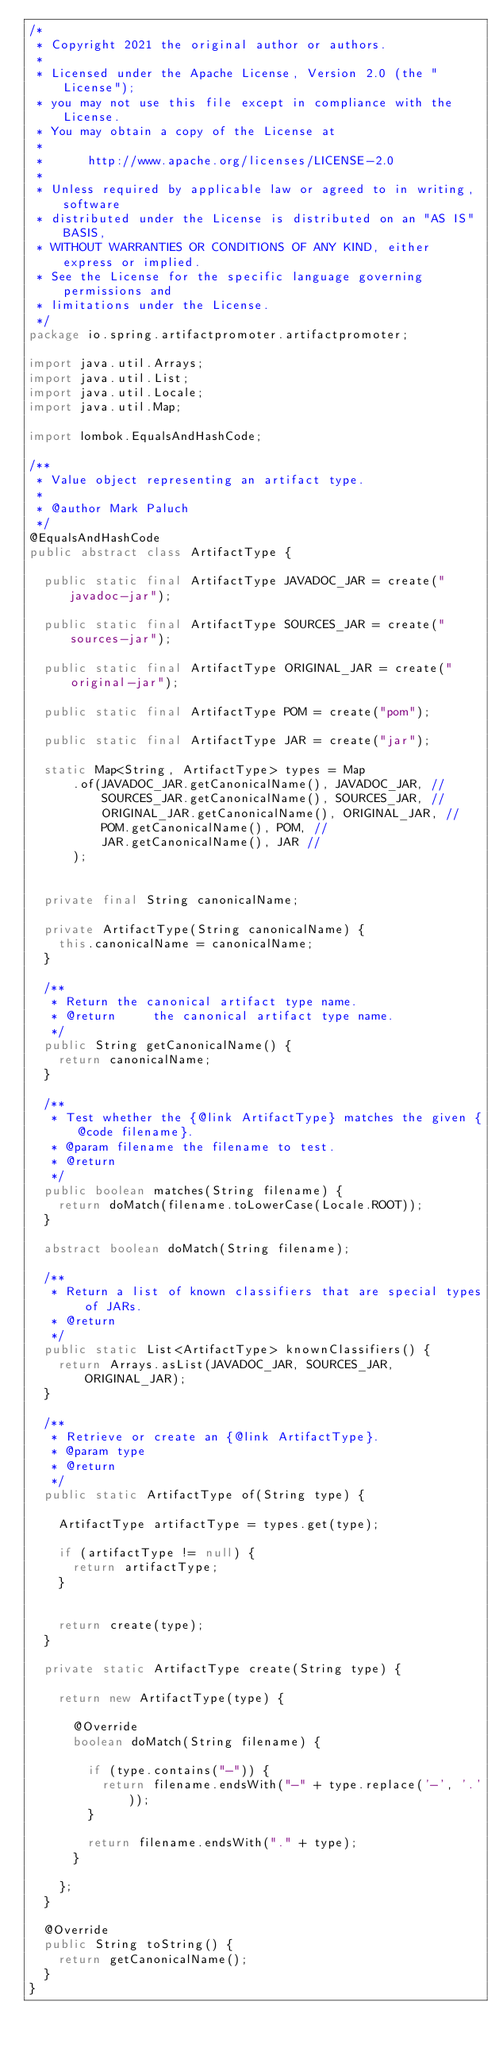Convert code to text. <code><loc_0><loc_0><loc_500><loc_500><_Java_>/*
 * Copyright 2021 the original author or authors.
 *
 * Licensed under the Apache License, Version 2.0 (the "License");
 * you may not use this file except in compliance with the License.
 * You may obtain a copy of the License at
 *
 *      http://www.apache.org/licenses/LICENSE-2.0
 *
 * Unless required by applicable law or agreed to in writing, software
 * distributed under the License is distributed on an "AS IS" BASIS,
 * WITHOUT WARRANTIES OR CONDITIONS OF ANY KIND, either express or implied.
 * See the License for the specific language governing permissions and
 * limitations under the License.
 */
package io.spring.artifactpromoter.artifactpromoter;

import java.util.Arrays;
import java.util.List;
import java.util.Locale;
import java.util.Map;

import lombok.EqualsAndHashCode;

/**
 * Value object representing an artifact type.
 *
 * @author Mark Paluch
 */
@EqualsAndHashCode
public abstract class ArtifactType {

	public static final ArtifactType JAVADOC_JAR = create("javadoc-jar");

	public static final ArtifactType SOURCES_JAR = create("sources-jar");

	public static final ArtifactType ORIGINAL_JAR = create("original-jar");

	public static final ArtifactType POM = create("pom");

	public static final ArtifactType JAR = create("jar");

	static Map<String, ArtifactType> types = Map
			.of(JAVADOC_JAR.getCanonicalName(), JAVADOC_JAR, //
					SOURCES_JAR.getCanonicalName(), SOURCES_JAR, //
					ORIGINAL_JAR.getCanonicalName(), ORIGINAL_JAR, //
					POM.getCanonicalName(), POM, //
					JAR.getCanonicalName(), JAR //
			);


	private final String canonicalName;

	private ArtifactType(String canonicalName) {
		this.canonicalName = canonicalName;
	}

	/**
	 * Return the canonical artifact type name.
	 * @return     the canonical artifact type name.
	 */
	public String getCanonicalName() {
		return canonicalName;
	}

	/**
	 * Test whether the {@link ArtifactType} matches the given {@code filename}.
	 * @param filename the filename to test.
	 * @return
	 */
	public boolean matches(String filename) {
		return doMatch(filename.toLowerCase(Locale.ROOT));
	}

	abstract boolean doMatch(String filename);

	/**
	 * Return a list of known classifiers that are special types of JARs.
	 * @return
	 */
	public static List<ArtifactType> knownClassifiers() {
		return Arrays.asList(JAVADOC_JAR, SOURCES_JAR, ORIGINAL_JAR);
	}

	/**
	 * Retrieve or create an {@link ArtifactType}.
	 * @param type
	 * @return
	 */
	public static ArtifactType of(String type) {

		ArtifactType artifactType = types.get(type);

		if (artifactType != null) {
			return artifactType;
		}


		return create(type);
	}

	private static ArtifactType create(String type) {

		return new ArtifactType(type) {

			@Override
			boolean doMatch(String filename) {

				if (type.contains("-")) {
					return filename.endsWith("-" + type.replace('-', '.'));
				}

				return filename.endsWith("." + type);
			}

		};
	}

	@Override
	public String toString() {
		return getCanonicalName();
	}
}
</code> 